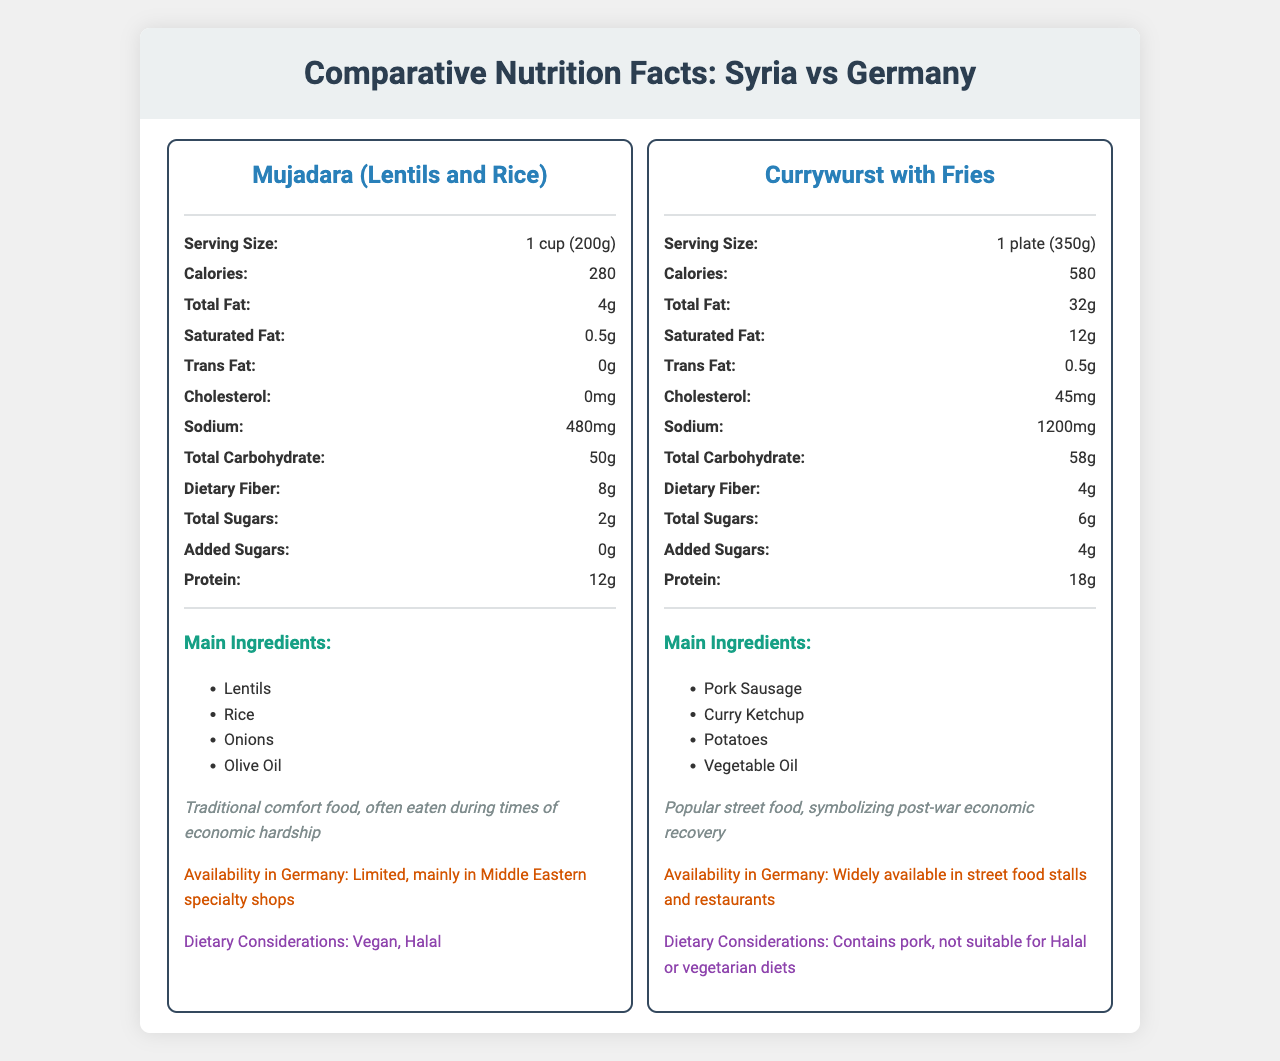What is the serving size of the meal from Syria? The serving size for the meal from Syria, Mujadara, is listed as 1 cup (200g) in the document.
Answer: 1 cup (200g) How many calories are in the asylum country meal? The nutritional information for Currywurst with Fries in Germany states that it contains 580 calories.
Answer: 580 Name one main ingredient in the asylum country meal. The document lists the main ingredients for Currywurst with Fries, including Pork Sausage.
Answer: Pork Sausage What is the total fat content in the home country meal? The total fat content for Mujadara (Lentils and Rice) from Syria is listed as 4g.
Answer: 4g What percentage of Vitamin C does the asylum country meal provide? The document states that the Currywurst with Fries meal provides 15% of the daily Vitamin C requirement.
Answer: 15% Which meal has a higher protein content? 
A. Mujadara 
B. Currywurst with Fries The document indicates that Mujadara has 12g of protein, while Currywurst with Fries has 18g of protein.
Answer: B What is the main cultural significance of the home country meal? 
A. Symbolizing post-war economic recovery 
B. Popular street food 
C. Traditional comfort food, often eaten during times of economic hardship 
D. Represents modern cuisine The document states that Mujadara is a traditional comfort food, often eaten during times of economic hardship.
Answer: C Does the home country meal contain any trans fat? The document indicates that the trans fat content for Mujadara is 0g.
Answer: No Summarize the main differences between the meals from Syria and Germany. The document provides detailed nutritional information, cultural significance, availability, and dietary considerations to highlight the differences between Mujadara and Currywurst with Fries.
Answer: The meal from Syria, Mujadara, is a traditional comfort food that is vegan and halal, and it is low in calories, fat, and cholesterol but high in fiber and inexpensive. In contrast, the German meal, Currywurst with Fries, is a popular street food high in calories, fat, sodium, and less fiber, costs more, and is not suitable for halal or vegetarian diets. Could the cost of ingredients be compared using the information in the document? The document does not provide specific ingredient costs for each meal, just the total meal price.
Answer: Not enough information What are the dietary considerations for the asylum country meal? The document notes that the Currywurst with Fries contains pork and is not suitable for Halal or vegetarian diets.
Answer: Contains pork, not suitable for Halal or vegetarian diets What percentage of iron does the home country meal provide? Mujadara provides 15% of the daily iron requirement according to the document.
Answer: 15% Is the home country meal widely available in the asylum country? The document states that Mujadara is limited in availability, mainly found in Middle Eastern specialty shops.
Answer: No 